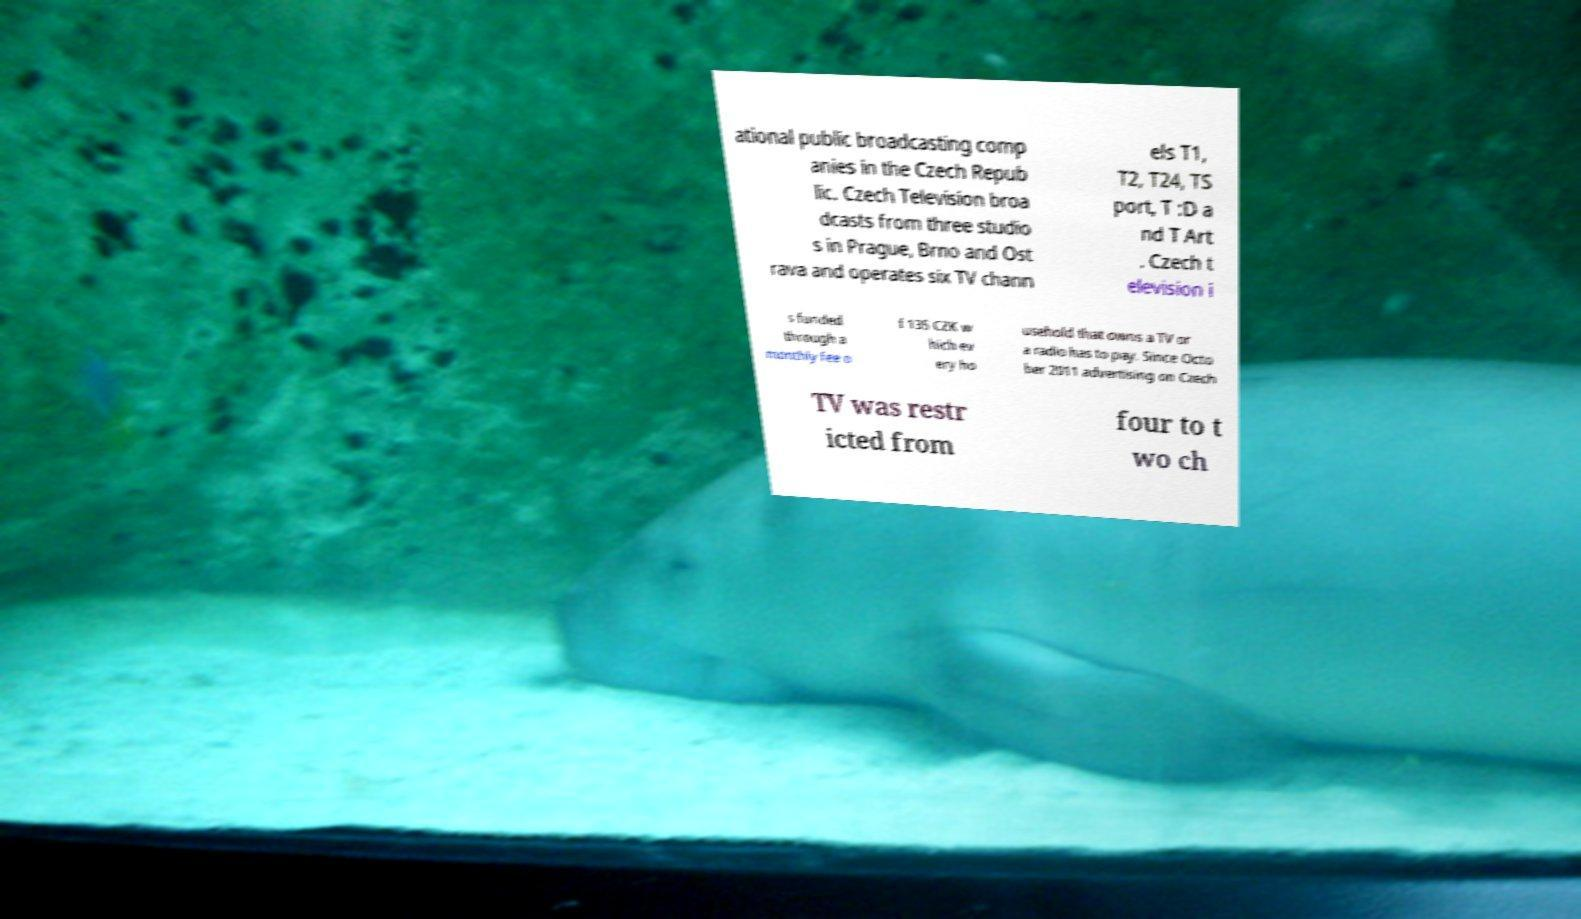What messages or text are displayed in this image? I need them in a readable, typed format. ational public broadcasting comp anies in the Czech Repub lic. Czech Television broa dcasts from three studio s in Prague, Brno and Ost rava and operates six TV chann els T1, T2, T24, TS port, T :D a nd T Art . Czech t elevision i s funded through a monthly fee o f 135 CZK w hich ev ery ho usehold that owns a TV or a radio has to pay. Since Octo ber 2011 advertising on Czech TV was restr icted from four to t wo ch 